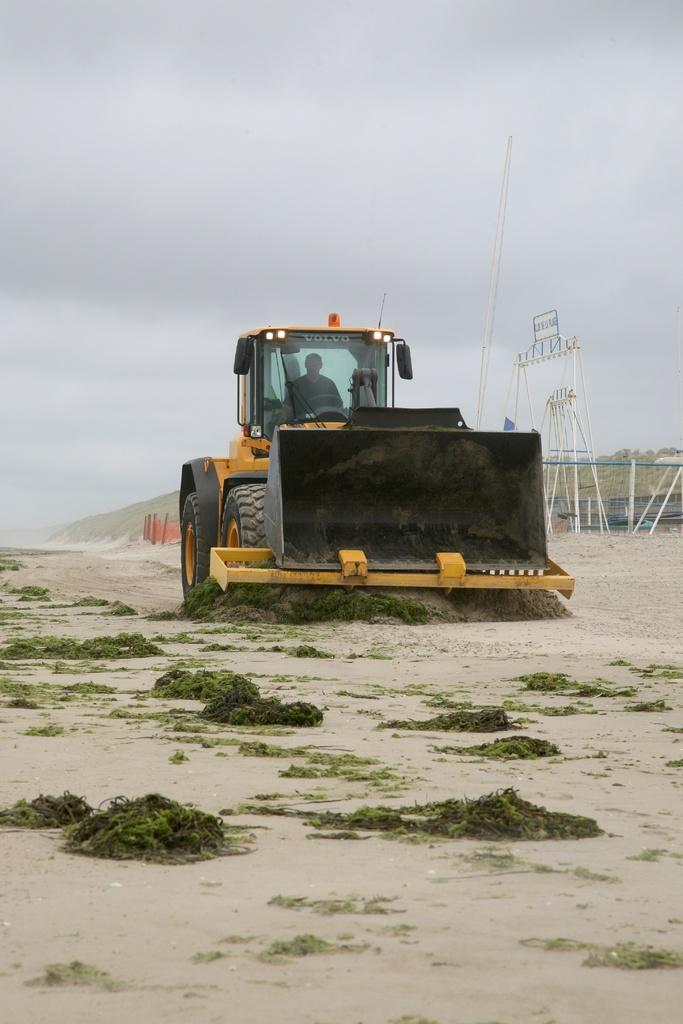What is the person in the image doing? There is a person driving a vehicle in the image. How would you describe the weather based on the image? The sky is cloudy in the image. What is present on the ground in the image? There is garbage on the ground in the image. What can be seen on the right side of the image? There are objects on the right side of the image. Can you tell me what type of wrench the person is using in the image? There is no wrench visible in the image. Is the person's uncle driving the vehicle in the image? The image does not provide any information about the person's relationship to an uncle. Can you see a frog in the image? There is no frog present in the image. 